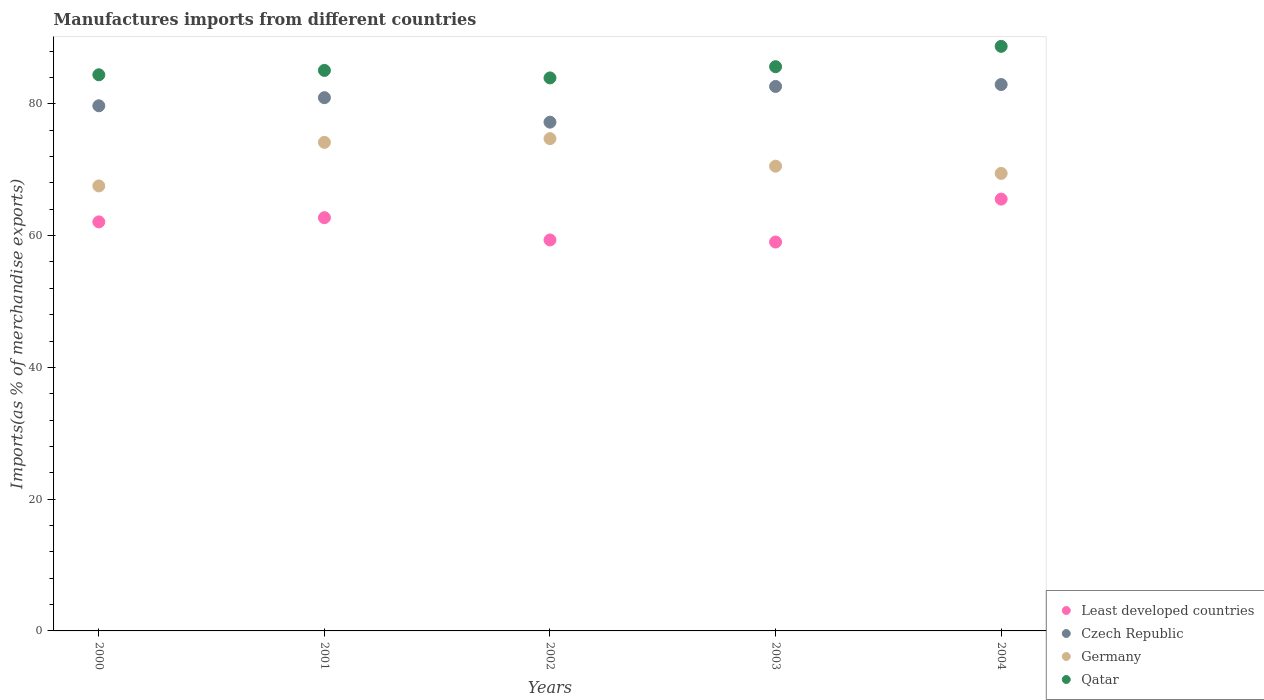What is the percentage of imports to different countries in Germany in 2004?
Give a very brief answer. 69.44. Across all years, what is the maximum percentage of imports to different countries in Least developed countries?
Give a very brief answer. 65.54. Across all years, what is the minimum percentage of imports to different countries in Qatar?
Provide a succinct answer. 83.93. In which year was the percentage of imports to different countries in Least developed countries maximum?
Your response must be concise. 2004. In which year was the percentage of imports to different countries in Germany minimum?
Keep it short and to the point. 2000. What is the total percentage of imports to different countries in Germany in the graph?
Offer a very short reply. 356.38. What is the difference between the percentage of imports to different countries in Qatar in 2002 and that in 2003?
Provide a succinct answer. -1.7. What is the difference between the percentage of imports to different countries in Qatar in 2004 and the percentage of imports to different countries in Czech Republic in 2003?
Make the answer very short. 6.08. What is the average percentage of imports to different countries in Germany per year?
Give a very brief answer. 71.28. In the year 2002, what is the difference between the percentage of imports to different countries in Germany and percentage of imports to different countries in Least developed countries?
Keep it short and to the point. 15.38. In how many years, is the percentage of imports to different countries in Czech Republic greater than 8 %?
Your answer should be compact. 5. What is the ratio of the percentage of imports to different countries in Czech Republic in 2000 to that in 2002?
Make the answer very short. 1.03. Is the percentage of imports to different countries in Qatar in 2000 less than that in 2001?
Ensure brevity in your answer.  Yes. Is the difference between the percentage of imports to different countries in Germany in 2002 and 2004 greater than the difference between the percentage of imports to different countries in Least developed countries in 2002 and 2004?
Give a very brief answer. Yes. What is the difference between the highest and the second highest percentage of imports to different countries in Germany?
Your answer should be compact. 0.56. What is the difference between the highest and the lowest percentage of imports to different countries in Qatar?
Your answer should be compact. 4.79. Is the sum of the percentage of imports to different countries in Qatar in 2002 and 2004 greater than the maximum percentage of imports to different countries in Least developed countries across all years?
Your answer should be compact. Yes. Is it the case that in every year, the sum of the percentage of imports to different countries in Germany and percentage of imports to different countries in Qatar  is greater than the sum of percentage of imports to different countries in Least developed countries and percentage of imports to different countries in Czech Republic?
Provide a short and direct response. Yes. Is it the case that in every year, the sum of the percentage of imports to different countries in Czech Republic and percentage of imports to different countries in Qatar  is greater than the percentage of imports to different countries in Least developed countries?
Make the answer very short. Yes. Is the percentage of imports to different countries in Least developed countries strictly greater than the percentage of imports to different countries in Germany over the years?
Provide a succinct answer. No. Is the percentage of imports to different countries in Qatar strictly less than the percentage of imports to different countries in Germany over the years?
Offer a very short reply. No. How many dotlines are there?
Your response must be concise. 4. How many years are there in the graph?
Provide a succinct answer. 5. Does the graph contain any zero values?
Ensure brevity in your answer.  No. Where does the legend appear in the graph?
Offer a terse response. Bottom right. How many legend labels are there?
Provide a succinct answer. 4. How are the legend labels stacked?
Provide a short and direct response. Vertical. What is the title of the graph?
Offer a terse response. Manufactures imports from different countries. What is the label or title of the X-axis?
Provide a short and direct response. Years. What is the label or title of the Y-axis?
Your answer should be compact. Imports(as % of merchandise exports). What is the Imports(as % of merchandise exports) in Least developed countries in 2000?
Provide a succinct answer. 62.08. What is the Imports(as % of merchandise exports) of Czech Republic in 2000?
Ensure brevity in your answer.  79.7. What is the Imports(as % of merchandise exports) of Germany in 2000?
Your response must be concise. 67.54. What is the Imports(as % of merchandise exports) of Qatar in 2000?
Provide a succinct answer. 84.41. What is the Imports(as % of merchandise exports) of Least developed countries in 2001?
Provide a succinct answer. 62.72. What is the Imports(as % of merchandise exports) of Czech Republic in 2001?
Your answer should be compact. 80.93. What is the Imports(as % of merchandise exports) in Germany in 2001?
Provide a succinct answer. 74.15. What is the Imports(as % of merchandise exports) in Qatar in 2001?
Your answer should be compact. 85.07. What is the Imports(as % of merchandise exports) in Least developed countries in 2002?
Offer a very short reply. 59.34. What is the Imports(as % of merchandise exports) in Czech Republic in 2002?
Provide a succinct answer. 77.22. What is the Imports(as % of merchandise exports) of Germany in 2002?
Your response must be concise. 74.72. What is the Imports(as % of merchandise exports) in Qatar in 2002?
Your response must be concise. 83.93. What is the Imports(as % of merchandise exports) of Least developed countries in 2003?
Provide a succinct answer. 59.02. What is the Imports(as % of merchandise exports) in Czech Republic in 2003?
Give a very brief answer. 82.64. What is the Imports(as % of merchandise exports) in Germany in 2003?
Your answer should be very brief. 70.54. What is the Imports(as % of merchandise exports) of Qatar in 2003?
Ensure brevity in your answer.  85.64. What is the Imports(as % of merchandise exports) in Least developed countries in 2004?
Your response must be concise. 65.54. What is the Imports(as % of merchandise exports) of Czech Republic in 2004?
Ensure brevity in your answer.  82.93. What is the Imports(as % of merchandise exports) in Germany in 2004?
Your response must be concise. 69.44. What is the Imports(as % of merchandise exports) of Qatar in 2004?
Keep it short and to the point. 88.72. Across all years, what is the maximum Imports(as % of merchandise exports) in Least developed countries?
Make the answer very short. 65.54. Across all years, what is the maximum Imports(as % of merchandise exports) of Czech Republic?
Provide a short and direct response. 82.93. Across all years, what is the maximum Imports(as % of merchandise exports) in Germany?
Keep it short and to the point. 74.72. Across all years, what is the maximum Imports(as % of merchandise exports) of Qatar?
Your answer should be very brief. 88.72. Across all years, what is the minimum Imports(as % of merchandise exports) in Least developed countries?
Offer a terse response. 59.02. Across all years, what is the minimum Imports(as % of merchandise exports) in Czech Republic?
Ensure brevity in your answer.  77.22. Across all years, what is the minimum Imports(as % of merchandise exports) of Germany?
Keep it short and to the point. 67.54. Across all years, what is the minimum Imports(as % of merchandise exports) in Qatar?
Give a very brief answer. 83.93. What is the total Imports(as % of merchandise exports) of Least developed countries in the graph?
Offer a very short reply. 308.71. What is the total Imports(as % of merchandise exports) in Czech Republic in the graph?
Give a very brief answer. 403.41. What is the total Imports(as % of merchandise exports) in Germany in the graph?
Ensure brevity in your answer.  356.38. What is the total Imports(as % of merchandise exports) in Qatar in the graph?
Provide a short and direct response. 427.77. What is the difference between the Imports(as % of merchandise exports) of Least developed countries in 2000 and that in 2001?
Your response must be concise. -0.64. What is the difference between the Imports(as % of merchandise exports) of Czech Republic in 2000 and that in 2001?
Offer a terse response. -1.23. What is the difference between the Imports(as % of merchandise exports) in Germany in 2000 and that in 2001?
Give a very brief answer. -6.61. What is the difference between the Imports(as % of merchandise exports) of Qatar in 2000 and that in 2001?
Give a very brief answer. -0.67. What is the difference between the Imports(as % of merchandise exports) of Least developed countries in 2000 and that in 2002?
Keep it short and to the point. 2.74. What is the difference between the Imports(as % of merchandise exports) in Czech Republic in 2000 and that in 2002?
Offer a terse response. 2.48. What is the difference between the Imports(as % of merchandise exports) of Germany in 2000 and that in 2002?
Give a very brief answer. -7.18. What is the difference between the Imports(as % of merchandise exports) of Qatar in 2000 and that in 2002?
Ensure brevity in your answer.  0.48. What is the difference between the Imports(as % of merchandise exports) of Least developed countries in 2000 and that in 2003?
Provide a succinct answer. 3.06. What is the difference between the Imports(as % of merchandise exports) of Czech Republic in 2000 and that in 2003?
Your answer should be very brief. -2.94. What is the difference between the Imports(as % of merchandise exports) in Germany in 2000 and that in 2003?
Keep it short and to the point. -3. What is the difference between the Imports(as % of merchandise exports) of Qatar in 2000 and that in 2003?
Provide a short and direct response. -1.23. What is the difference between the Imports(as % of merchandise exports) of Least developed countries in 2000 and that in 2004?
Your answer should be very brief. -3.46. What is the difference between the Imports(as % of merchandise exports) of Czech Republic in 2000 and that in 2004?
Offer a very short reply. -3.22. What is the difference between the Imports(as % of merchandise exports) in Germany in 2000 and that in 2004?
Your response must be concise. -1.9. What is the difference between the Imports(as % of merchandise exports) of Qatar in 2000 and that in 2004?
Ensure brevity in your answer.  -4.32. What is the difference between the Imports(as % of merchandise exports) in Least developed countries in 2001 and that in 2002?
Offer a terse response. 3.38. What is the difference between the Imports(as % of merchandise exports) of Czech Republic in 2001 and that in 2002?
Provide a succinct answer. 3.71. What is the difference between the Imports(as % of merchandise exports) in Germany in 2001 and that in 2002?
Make the answer very short. -0.56. What is the difference between the Imports(as % of merchandise exports) in Qatar in 2001 and that in 2002?
Provide a succinct answer. 1.14. What is the difference between the Imports(as % of merchandise exports) in Least developed countries in 2001 and that in 2003?
Ensure brevity in your answer.  3.7. What is the difference between the Imports(as % of merchandise exports) of Czech Republic in 2001 and that in 2003?
Offer a terse response. -1.71. What is the difference between the Imports(as % of merchandise exports) of Germany in 2001 and that in 2003?
Give a very brief answer. 3.62. What is the difference between the Imports(as % of merchandise exports) of Qatar in 2001 and that in 2003?
Your response must be concise. -0.56. What is the difference between the Imports(as % of merchandise exports) in Least developed countries in 2001 and that in 2004?
Offer a very short reply. -2.82. What is the difference between the Imports(as % of merchandise exports) in Czech Republic in 2001 and that in 2004?
Provide a succinct answer. -1.99. What is the difference between the Imports(as % of merchandise exports) of Germany in 2001 and that in 2004?
Your answer should be compact. 4.71. What is the difference between the Imports(as % of merchandise exports) in Qatar in 2001 and that in 2004?
Keep it short and to the point. -3.65. What is the difference between the Imports(as % of merchandise exports) in Least developed countries in 2002 and that in 2003?
Your response must be concise. 0.32. What is the difference between the Imports(as % of merchandise exports) of Czech Republic in 2002 and that in 2003?
Your response must be concise. -5.42. What is the difference between the Imports(as % of merchandise exports) of Germany in 2002 and that in 2003?
Provide a succinct answer. 4.18. What is the difference between the Imports(as % of merchandise exports) in Qatar in 2002 and that in 2003?
Keep it short and to the point. -1.7. What is the difference between the Imports(as % of merchandise exports) of Least developed countries in 2002 and that in 2004?
Provide a succinct answer. -6.2. What is the difference between the Imports(as % of merchandise exports) in Czech Republic in 2002 and that in 2004?
Provide a succinct answer. -5.71. What is the difference between the Imports(as % of merchandise exports) of Germany in 2002 and that in 2004?
Provide a succinct answer. 5.28. What is the difference between the Imports(as % of merchandise exports) of Qatar in 2002 and that in 2004?
Offer a terse response. -4.79. What is the difference between the Imports(as % of merchandise exports) of Least developed countries in 2003 and that in 2004?
Your answer should be very brief. -6.52. What is the difference between the Imports(as % of merchandise exports) in Czech Republic in 2003 and that in 2004?
Offer a very short reply. -0.29. What is the difference between the Imports(as % of merchandise exports) in Germany in 2003 and that in 2004?
Provide a short and direct response. 1.1. What is the difference between the Imports(as % of merchandise exports) of Qatar in 2003 and that in 2004?
Keep it short and to the point. -3.09. What is the difference between the Imports(as % of merchandise exports) in Least developed countries in 2000 and the Imports(as % of merchandise exports) in Czech Republic in 2001?
Provide a succinct answer. -18.85. What is the difference between the Imports(as % of merchandise exports) in Least developed countries in 2000 and the Imports(as % of merchandise exports) in Germany in 2001?
Offer a very short reply. -12.07. What is the difference between the Imports(as % of merchandise exports) of Least developed countries in 2000 and the Imports(as % of merchandise exports) of Qatar in 2001?
Your response must be concise. -22.99. What is the difference between the Imports(as % of merchandise exports) of Czech Republic in 2000 and the Imports(as % of merchandise exports) of Germany in 2001?
Provide a short and direct response. 5.55. What is the difference between the Imports(as % of merchandise exports) of Czech Republic in 2000 and the Imports(as % of merchandise exports) of Qatar in 2001?
Offer a terse response. -5.37. What is the difference between the Imports(as % of merchandise exports) in Germany in 2000 and the Imports(as % of merchandise exports) in Qatar in 2001?
Your answer should be very brief. -17.53. What is the difference between the Imports(as % of merchandise exports) of Least developed countries in 2000 and the Imports(as % of merchandise exports) of Czech Republic in 2002?
Your answer should be compact. -15.14. What is the difference between the Imports(as % of merchandise exports) in Least developed countries in 2000 and the Imports(as % of merchandise exports) in Germany in 2002?
Your response must be concise. -12.63. What is the difference between the Imports(as % of merchandise exports) of Least developed countries in 2000 and the Imports(as % of merchandise exports) of Qatar in 2002?
Your answer should be very brief. -21.85. What is the difference between the Imports(as % of merchandise exports) in Czech Republic in 2000 and the Imports(as % of merchandise exports) in Germany in 2002?
Provide a short and direct response. 4.99. What is the difference between the Imports(as % of merchandise exports) in Czech Republic in 2000 and the Imports(as % of merchandise exports) in Qatar in 2002?
Give a very brief answer. -4.23. What is the difference between the Imports(as % of merchandise exports) in Germany in 2000 and the Imports(as % of merchandise exports) in Qatar in 2002?
Offer a terse response. -16.39. What is the difference between the Imports(as % of merchandise exports) in Least developed countries in 2000 and the Imports(as % of merchandise exports) in Czech Republic in 2003?
Give a very brief answer. -20.56. What is the difference between the Imports(as % of merchandise exports) in Least developed countries in 2000 and the Imports(as % of merchandise exports) in Germany in 2003?
Ensure brevity in your answer.  -8.45. What is the difference between the Imports(as % of merchandise exports) of Least developed countries in 2000 and the Imports(as % of merchandise exports) of Qatar in 2003?
Provide a short and direct response. -23.55. What is the difference between the Imports(as % of merchandise exports) of Czech Republic in 2000 and the Imports(as % of merchandise exports) of Germany in 2003?
Give a very brief answer. 9.17. What is the difference between the Imports(as % of merchandise exports) of Czech Republic in 2000 and the Imports(as % of merchandise exports) of Qatar in 2003?
Ensure brevity in your answer.  -5.93. What is the difference between the Imports(as % of merchandise exports) in Germany in 2000 and the Imports(as % of merchandise exports) in Qatar in 2003?
Ensure brevity in your answer.  -18.1. What is the difference between the Imports(as % of merchandise exports) of Least developed countries in 2000 and the Imports(as % of merchandise exports) of Czech Republic in 2004?
Keep it short and to the point. -20.84. What is the difference between the Imports(as % of merchandise exports) in Least developed countries in 2000 and the Imports(as % of merchandise exports) in Germany in 2004?
Offer a terse response. -7.36. What is the difference between the Imports(as % of merchandise exports) in Least developed countries in 2000 and the Imports(as % of merchandise exports) in Qatar in 2004?
Your answer should be very brief. -26.64. What is the difference between the Imports(as % of merchandise exports) in Czech Republic in 2000 and the Imports(as % of merchandise exports) in Germany in 2004?
Give a very brief answer. 10.26. What is the difference between the Imports(as % of merchandise exports) in Czech Republic in 2000 and the Imports(as % of merchandise exports) in Qatar in 2004?
Your response must be concise. -9.02. What is the difference between the Imports(as % of merchandise exports) in Germany in 2000 and the Imports(as % of merchandise exports) in Qatar in 2004?
Your answer should be very brief. -21.18. What is the difference between the Imports(as % of merchandise exports) in Least developed countries in 2001 and the Imports(as % of merchandise exports) in Czech Republic in 2002?
Make the answer very short. -14.5. What is the difference between the Imports(as % of merchandise exports) of Least developed countries in 2001 and the Imports(as % of merchandise exports) of Germany in 2002?
Ensure brevity in your answer.  -12. What is the difference between the Imports(as % of merchandise exports) of Least developed countries in 2001 and the Imports(as % of merchandise exports) of Qatar in 2002?
Ensure brevity in your answer.  -21.21. What is the difference between the Imports(as % of merchandise exports) of Czech Republic in 2001 and the Imports(as % of merchandise exports) of Germany in 2002?
Offer a very short reply. 6.22. What is the difference between the Imports(as % of merchandise exports) in Czech Republic in 2001 and the Imports(as % of merchandise exports) in Qatar in 2002?
Provide a short and direct response. -3. What is the difference between the Imports(as % of merchandise exports) in Germany in 2001 and the Imports(as % of merchandise exports) in Qatar in 2002?
Make the answer very short. -9.78. What is the difference between the Imports(as % of merchandise exports) in Least developed countries in 2001 and the Imports(as % of merchandise exports) in Czech Republic in 2003?
Provide a succinct answer. -19.92. What is the difference between the Imports(as % of merchandise exports) in Least developed countries in 2001 and the Imports(as % of merchandise exports) in Germany in 2003?
Provide a short and direct response. -7.82. What is the difference between the Imports(as % of merchandise exports) in Least developed countries in 2001 and the Imports(as % of merchandise exports) in Qatar in 2003?
Your response must be concise. -22.91. What is the difference between the Imports(as % of merchandise exports) of Czech Republic in 2001 and the Imports(as % of merchandise exports) of Germany in 2003?
Keep it short and to the point. 10.39. What is the difference between the Imports(as % of merchandise exports) of Czech Republic in 2001 and the Imports(as % of merchandise exports) of Qatar in 2003?
Make the answer very short. -4.7. What is the difference between the Imports(as % of merchandise exports) in Germany in 2001 and the Imports(as % of merchandise exports) in Qatar in 2003?
Offer a terse response. -11.48. What is the difference between the Imports(as % of merchandise exports) of Least developed countries in 2001 and the Imports(as % of merchandise exports) of Czech Republic in 2004?
Keep it short and to the point. -20.21. What is the difference between the Imports(as % of merchandise exports) in Least developed countries in 2001 and the Imports(as % of merchandise exports) in Germany in 2004?
Your answer should be compact. -6.72. What is the difference between the Imports(as % of merchandise exports) in Least developed countries in 2001 and the Imports(as % of merchandise exports) in Qatar in 2004?
Offer a very short reply. -26. What is the difference between the Imports(as % of merchandise exports) in Czech Republic in 2001 and the Imports(as % of merchandise exports) in Germany in 2004?
Offer a terse response. 11.49. What is the difference between the Imports(as % of merchandise exports) in Czech Republic in 2001 and the Imports(as % of merchandise exports) in Qatar in 2004?
Offer a very short reply. -7.79. What is the difference between the Imports(as % of merchandise exports) in Germany in 2001 and the Imports(as % of merchandise exports) in Qatar in 2004?
Your answer should be very brief. -14.57. What is the difference between the Imports(as % of merchandise exports) of Least developed countries in 2002 and the Imports(as % of merchandise exports) of Czech Republic in 2003?
Ensure brevity in your answer.  -23.3. What is the difference between the Imports(as % of merchandise exports) in Least developed countries in 2002 and the Imports(as % of merchandise exports) in Germany in 2003?
Make the answer very short. -11.2. What is the difference between the Imports(as % of merchandise exports) of Least developed countries in 2002 and the Imports(as % of merchandise exports) of Qatar in 2003?
Provide a short and direct response. -26.3. What is the difference between the Imports(as % of merchandise exports) of Czech Republic in 2002 and the Imports(as % of merchandise exports) of Germany in 2003?
Ensure brevity in your answer.  6.68. What is the difference between the Imports(as % of merchandise exports) of Czech Republic in 2002 and the Imports(as % of merchandise exports) of Qatar in 2003?
Offer a terse response. -8.42. What is the difference between the Imports(as % of merchandise exports) of Germany in 2002 and the Imports(as % of merchandise exports) of Qatar in 2003?
Your answer should be very brief. -10.92. What is the difference between the Imports(as % of merchandise exports) in Least developed countries in 2002 and the Imports(as % of merchandise exports) in Czech Republic in 2004?
Provide a short and direct response. -23.59. What is the difference between the Imports(as % of merchandise exports) of Least developed countries in 2002 and the Imports(as % of merchandise exports) of Germany in 2004?
Provide a succinct answer. -10.1. What is the difference between the Imports(as % of merchandise exports) in Least developed countries in 2002 and the Imports(as % of merchandise exports) in Qatar in 2004?
Provide a succinct answer. -29.38. What is the difference between the Imports(as % of merchandise exports) of Czech Republic in 2002 and the Imports(as % of merchandise exports) of Germany in 2004?
Your answer should be compact. 7.78. What is the difference between the Imports(as % of merchandise exports) of Czech Republic in 2002 and the Imports(as % of merchandise exports) of Qatar in 2004?
Make the answer very short. -11.5. What is the difference between the Imports(as % of merchandise exports) in Germany in 2002 and the Imports(as % of merchandise exports) in Qatar in 2004?
Offer a terse response. -14.01. What is the difference between the Imports(as % of merchandise exports) of Least developed countries in 2003 and the Imports(as % of merchandise exports) of Czech Republic in 2004?
Keep it short and to the point. -23.9. What is the difference between the Imports(as % of merchandise exports) in Least developed countries in 2003 and the Imports(as % of merchandise exports) in Germany in 2004?
Provide a short and direct response. -10.41. What is the difference between the Imports(as % of merchandise exports) in Least developed countries in 2003 and the Imports(as % of merchandise exports) in Qatar in 2004?
Your answer should be compact. -29.7. What is the difference between the Imports(as % of merchandise exports) of Czech Republic in 2003 and the Imports(as % of merchandise exports) of Germany in 2004?
Keep it short and to the point. 13.2. What is the difference between the Imports(as % of merchandise exports) in Czech Republic in 2003 and the Imports(as % of merchandise exports) in Qatar in 2004?
Your answer should be compact. -6.08. What is the difference between the Imports(as % of merchandise exports) in Germany in 2003 and the Imports(as % of merchandise exports) in Qatar in 2004?
Keep it short and to the point. -18.18. What is the average Imports(as % of merchandise exports) in Least developed countries per year?
Make the answer very short. 61.74. What is the average Imports(as % of merchandise exports) in Czech Republic per year?
Provide a succinct answer. 80.68. What is the average Imports(as % of merchandise exports) of Germany per year?
Offer a very short reply. 71.28. What is the average Imports(as % of merchandise exports) of Qatar per year?
Your answer should be compact. 85.55. In the year 2000, what is the difference between the Imports(as % of merchandise exports) in Least developed countries and Imports(as % of merchandise exports) in Czech Republic?
Give a very brief answer. -17.62. In the year 2000, what is the difference between the Imports(as % of merchandise exports) in Least developed countries and Imports(as % of merchandise exports) in Germany?
Make the answer very short. -5.46. In the year 2000, what is the difference between the Imports(as % of merchandise exports) in Least developed countries and Imports(as % of merchandise exports) in Qatar?
Your answer should be very brief. -22.32. In the year 2000, what is the difference between the Imports(as % of merchandise exports) in Czech Republic and Imports(as % of merchandise exports) in Germany?
Provide a succinct answer. 12.16. In the year 2000, what is the difference between the Imports(as % of merchandise exports) of Czech Republic and Imports(as % of merchandise exports) of Qatar?
Ensure brevity in your answer.  -4.7. In the year 2000, what is the difference between the Imports(as % of merchandise exports) of Germany and Imports(as % of merchandise exports) of Qatar?
Give a very brief answer. -16.87. In the year 2001, what is the difference between the Imports(as % of merchandise exports) of Least developed countries and Imports(as % of merchandise exports) of Czech Republic?
Ensure brevity in your answer.  -18.21. In the year 2001, what is the difference between the Imports(as % of merchandise exports) in Least developed countries and Imports(as % of merchandise exports) in Germany?
Offer a terse response. -11.43. In the year 2001, what is the difference between the Imports(as % of merchandise exports) of Least developed countries and Imports(as % of merchandise exports) of Qatar?
Ensure brevity in your answer.  -22.35. In the year 2001, what is the difference between the Imports(as % of merchandise exports) of Czech Republic and Imports(as % of merchandise exports) of Germany?
Make the answer very short. 6.78. In the year 2001, what is the difference between the Imports(as % of merchandise exports) in Czech Republic and Imports(as % of merchandise exports) in Qatar?
Ensure brevity in your answer.  -4.14. In the year 2001, what is the difference between the Imports(as % of merchandise exports) in Germany and Imports(as % of merchandise exports) in Qatar?
Provide a short and direct response. -10.92. In the year 2002, what is the difference between the Imports(as % of merchandise exports) of Least developed countries and Imports(as % of merchandise exports) of Czech Republic?
Make the answer very short. -17.88. In the year 2002, what is the difference between the Imports(as % of merchandise exports) of Least developed countries and Imports(as % of merchandise exports) of Germany?
Offer a terse response. -15.38. In the year 2002, what is the difference between the Imports(as % of merchandise exports) of Least developed countries and Imports(as % of merchandise exports) of Qatar?
Give a very brief answer. -24.59. In the year 2002, what is the difference between the Imports(as % of merchandise exports) of Czech Republic and Imports(as % of merchandise exports) of Germany?
Give a very brief answer. 2.5. In the year 2002, what is the difference between the Imports(as % of merchandise exports) in Czech Republic and Imports(as % of merchandise exports) in Qatar?
Your answer should be very brief. -6.71. In the year 2002, what is the difference between the Imports(as % of merchandise exports) of Germany and Imports(as % of merchandise exports) of Qatar?
Provide a succinct answer. -9.22. In the year 2003, what is the difference between the Imports(as % of merchandise exports) of Least developed countries and Imports(as % of merchandise exports) of Czech Republic?
Provide a short and direct response. -23.61. In the year 2003, what is the difference between the Imports(as % of merchandise exports) of Least developed countries and Imports(as % of merchandise exports) of Germany?
Make the answer very short. -11.51. In the year 2003, what is the difference between the Imports(as % of merchandise exports) in Least developed countries and Imports(as % of merchandise exports) in Qatar?
Ensure brevity in your answer.  -26.61. In the year 2003, what is the difference between the Imports(as % of merchandise exports) in Czech Republic and Imports(as % of merchandise exports) in Germany?
Keep it short and to the point. 12.1. In the year 2003, what is the difference between the Imports(as % of merchandise exports) in Czech Republic and Imports(as % of merchandise exports) in Qatar?
Your answer should be compact. -3. In the year 2003, what is the difference between the Imports(as % of merchandise exports) in Germany and Imports(as % of merchandise exports) in Qatar?
Provide a succinct answer. -15.1. In the year 2004, what is the difference between the Imports(as % of merchandise exports) in Least developed countries and Imports(as % of merchandise exports) in Czech Republic?
Ensure brevity in your answer.  -17.39. In the year 2004, what is the difference between the Imports(as % of merchandise exports) of Least developed countries and Imports(as % of merchandise exports) of Germany?
Give a very brief answer. -3.9. In the year 2004, what is the difference between the Imports(as % of merchandise exports) of Least developed countries and Imports(as % of merchandise exports) of Qatar?
Keep it short and to the point. -23.18. In the year 2004, what is the difference between the Imports(as % of merchandise exports) in Czech Republic and Imports(as % of merchandise exports) in Germany?
Offer a very short reply. 13.49. In the year 2004, what is the difference between the Imports(as % of merchandise exports) in Czech Republic and Imports(as % of merchandise exports) in Qatar?
Keep it short and to the point. -5.8. In the year 2004, what is the difference between the Imports(as % of merchandise exports) of Germany and Imports(as % of merchandise exports) of Qatar?
Ensure brevity in your answer.  -19.28. What is the ratio of the Imports(as % of merchandise exports) of Least developed countries in 2000 to that in 2001?
Give a very brief answer. 0.99. What is the ratio of the Imports(as % of merchandise exports) of Germany in 2000 to that in 2001?
Your answer should be very brief. 0.91. What is the ratio of the Imports(as % of merchandise exports) in Qatar in 2000 to that in 2001?
Keep it short and to the point. 0.99. What is the ratio of the Imports(as % of merchandise exports) in Least developed countries in 2000 to that in 2002?
Your answer should be compact. 1.05. What is the ratio of the Imports(as % of merchandise exports) of Czech Republic in 2000 to that in 2002?
Make the answer very short. 1.03. What is the ratio of the Imports(as % of merchandise exports) of Germany in 2000 to that in 2002?
Provide a short and direct response. 0.9. What is the ratio of the Imports(as % of merchandise exports) of Qatar in 2000 to that in 2002?
Offer a terse response. 1.01. What is the ratio of the Imports(as % of merchandise exports) of Least developed countries in 2000 to that in 2003?
Your answer should be compact. 1.05. What is the ratio of the Imports(as % of merchandise exports) in Czech Republic in 2000 to that in 2003?
Your answer should be very brief. 0.96. What is the ratio of the Imports(as % of merchandise exports) in Germany in 2000 to that in 2003?
Give a very brief answer. 0.96. What is the ratio of the Imports(as % of merchandise exports) of Qatar in 2000 to that in 2003?
Provide a succinct answer. 0.99. What is the ratio of the Imports(as % of merchandise exports) of Least developed countries in 2000 to that in 2004?
Make the answer very short. 0.95. What is the ratio of the Imports(as % of merchandise exports) in Czech Republic in 2000 to that in 2004?
Provide a succinct answer. 0.96. What is the ratio of the Imports(as % of merchandise exports) in Germany in 2000 to that in 2004?
Ensure brevity in your answer.  0.97. What is the ratio of the Imports(as % of merchandise exports) of Qatar in 2000 to that in 2004?
Your response must be concise. 0.95. What is the ratio of the Imports(as % of merchandise exports) in Least developed countries in 2001 to that in 2002?
Your response must be concise. 1.06. What is the ratio of the Imports(as % of merchandise exports) in Czech Republic in 2001 to that in 2002?
Keep it short and to the point. 1.05. What is the ratio of the Imports(as % of merchandise exports) in Qatar in 2001 to that in 2002?
Your answer should be very brief. 1.01. What is the ratio of the Imports(as % of merchandise exports) in Least developed countries in 2001 to that in 2003?
Provide a succinct answer. 1.06. What is the ratio of the Imports(as % of merchandise exports) of Czech Republic in 2001 to that in 2003?
Offer a very short reply. 0.98. What is the ratio of the Imports(as % of merchandise exports) in Germany in 2001 to that in 2003?
Offer a very short reply. 1.05. What is the ratio of the Imports(as % of merchandise exports) in Qatar in 2001 to that in 2003?
Ensure brevity in your answer.  0.99. What is the ratio of the Imports(as % of merchandise exports) in Least developed countries in 2001 to that in 2004?
Provide a succinct answer. 0.96. What is the ratio of the Imports(as % of merchandise exports) of Czech Republic in 2001 to that in 2004?
Your answer should be very brief. 0.98. What is the ratio of the Imports(as % of merchandise exports) of Germany in 2001 to that in 2004?
Keep it short and to the point. 1.07. What is the ratio of the Imports(as % of merchandise exports) of Qatar in 2001 to that in 2004?
Give a very brief answer. 0.96. What is the ratio of the Imports(as % of merchandise exports) in Czech Republic in 2002 to that in 2003?
Make the answer very short. 0.93. What is the ratio of the Imports(as % of merchandise exports) of Germany in 2002 to that in 2003?
Ensure brevity in your answer.  1.06. What is the ratio of the Imports(as % of merchandise exports) of Qatar in 2002 to that in 2003?
Provide a short and direct response. 0.98. What is the ratio of the Imports(as % of merchandise exports) in Least developed countries in 2002 to that in 2004?
Your answer should be very brief. 0.91. What is the ratio of the Imports(as % of merchandise exports) in Czech Republic in 2002 to that in 2004?
Provide a short and direct response. 0.93. What is the ratio of the Imports(as % of merchandise exports) of Germany in 2002 to that in 2004?
Provide a succinct answer. 1.08. What is the ratio of the Imports(as % of merchandise exports) in Qatar in 2002 to that in 2004?
Offer a terse response. 0.95. What is the ratio of the Imports(as % of merchandise exports) in Least developed countries in 2003 to that in 2004?
Ensure brevity in your answer.  0.9. What is the ratio of the Imports(as % of merchandise exports) of Germany in 2003 to that in 2004?
Your answer should be compact. 1.02. What is the ratio of the Imports(as % of merchandise exports) in Qatar in 2003 to that in 2004?
Offer a very short reply. 0.97. What is the difference between the highest and the second highest Imports(as % of merchandise exports) in Least developed countries?
Offer a terse response. 2.82. What is the difference between the highest and the second highest Imports(as % of merchandise exports) of Czech Republic?
Your response must be concise. 0.29. What is the difference between the highest and the second highest Imports(as % of merchandise exports) in Germany?
Give a very brief answer. 0.56. What is the difference between the highest and the second highest Imports(as % of merchandise exports) in Qatar?
Make the answer very short. 3.09. What is the difference between the highest and the lowest Imports(as % of merchandise exports) of Least developed countries?
Provide a short and direct response. 6.52. What is the difference between the highest and the lowest Imports(as % of merchandise exports) in Czech Republic?
Your answer should be compact. 5.71. What is the difference between the highest and the lowest Imports(as % of merchandise exports) of Germany?
Ensure brevity in your answer.  7.18. What is the difference between the highest and the lowest Imports(as % of merchandise exports) in Qatar?
Your response must be concise. 4.79. 